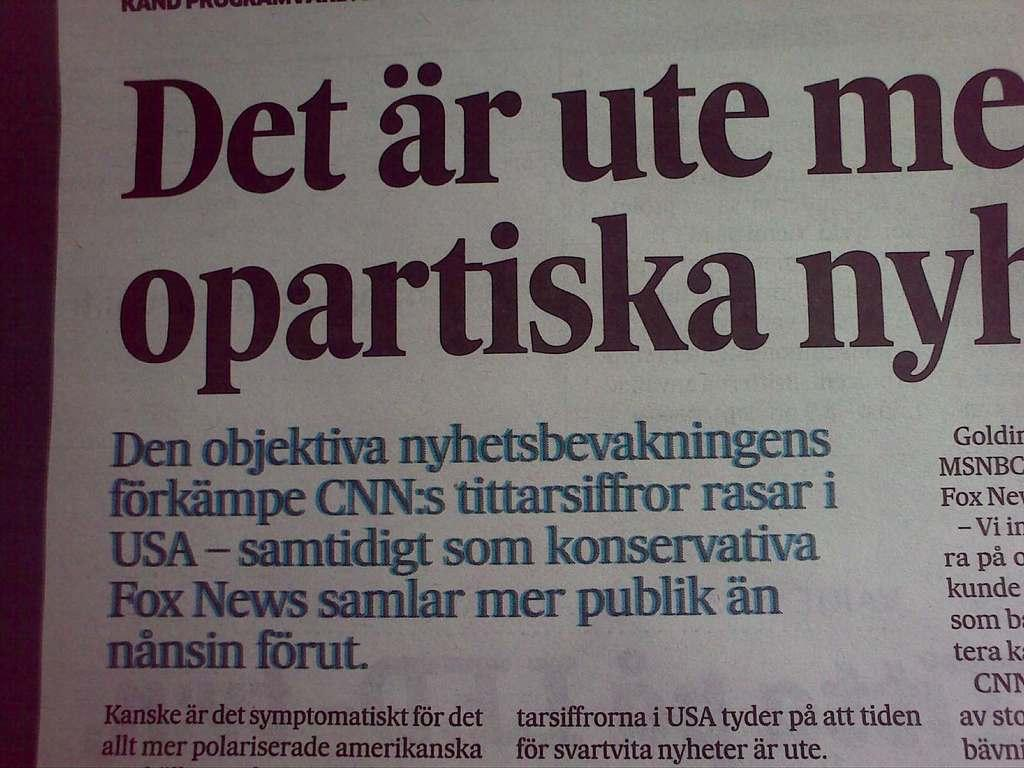Provide a one-sentence caption for the provided image. Newsprint in a language other than English includes something about CNN. 